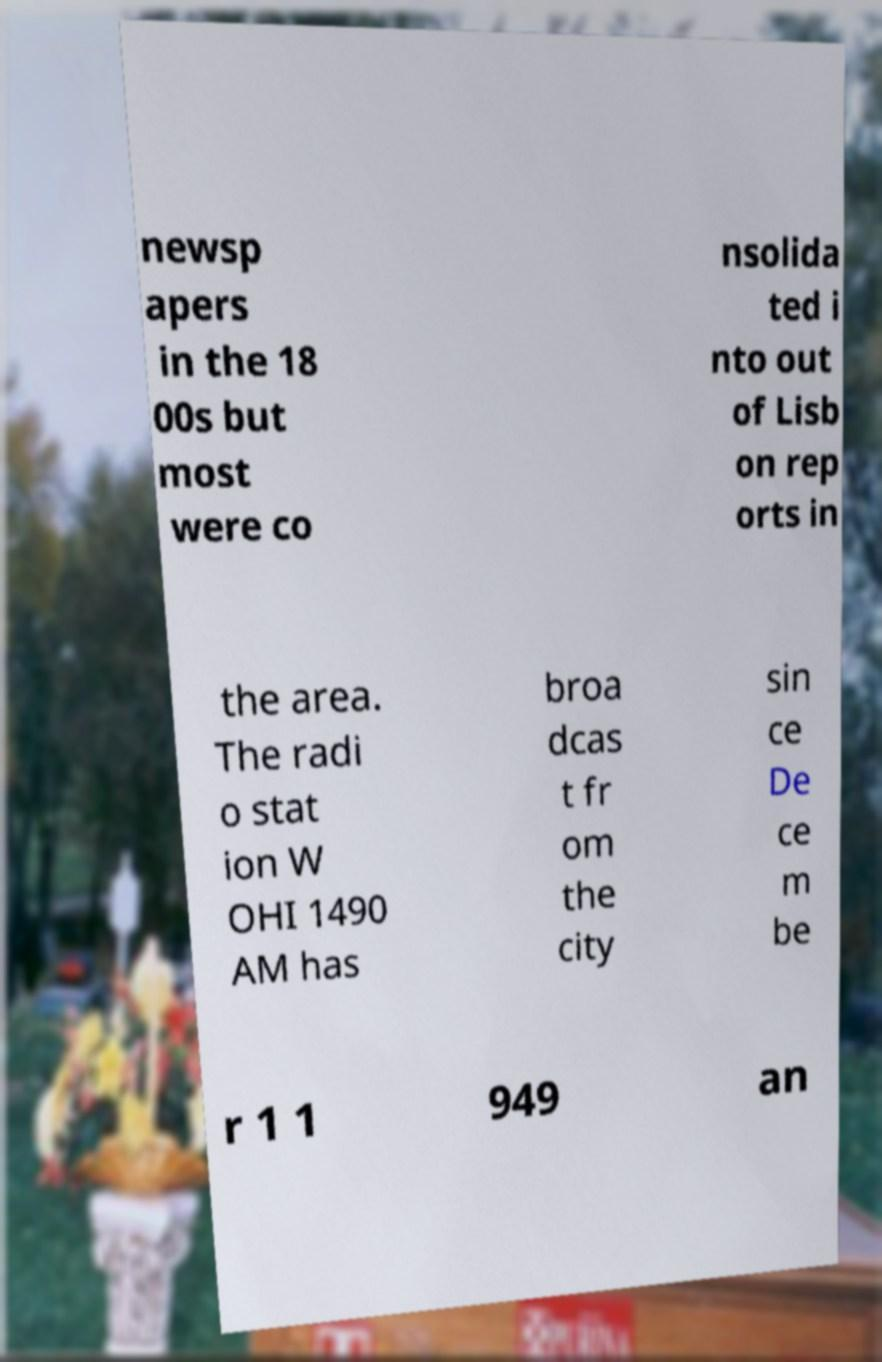I need the written content from this picture converted into text. Can you do that? newsp apers in the 18 00s but most were co nsolida ted i nto out of Lisb on rep orts in the area. The radi o stat ion W OHI 1490 AM has broa dcas t fr om the city sin ce De ce m be r 1 1 949 an 